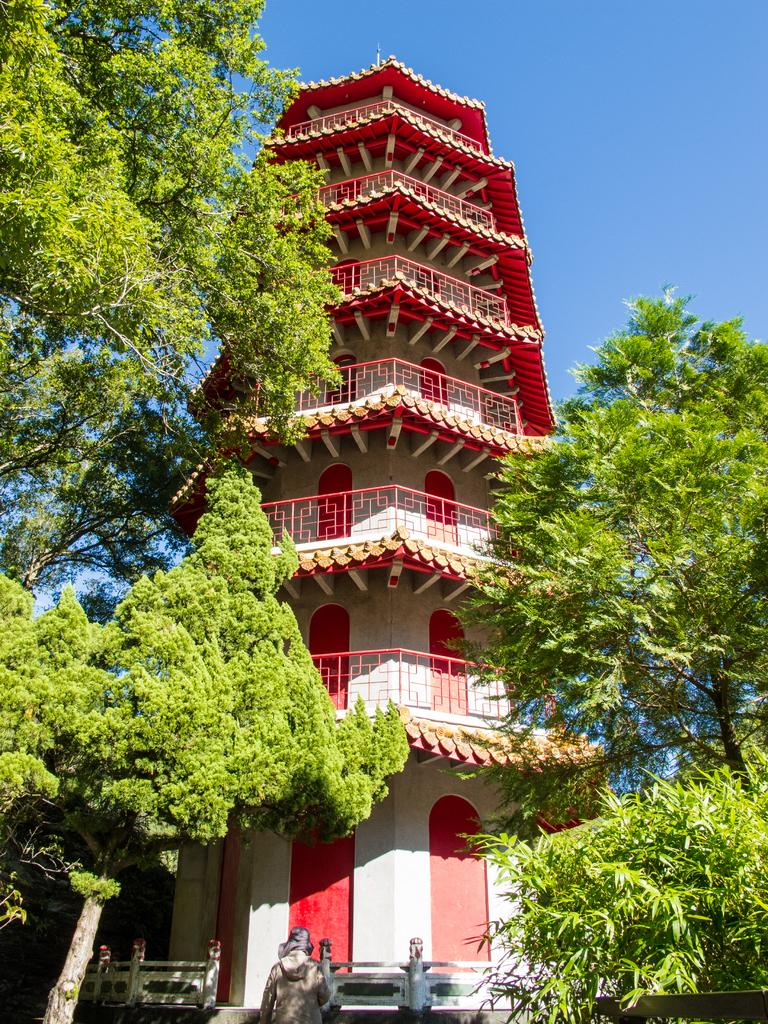What is the main subject in the middle of the image? There is a big structure in the middle of the image. What type of vegetation can be seen in the image? There are green trees in the image. What color is the sky at the top of the image? The sky is blue in color at the top of the image. Where is the partner sitting on the sofa in the image? There is no sofa or partner present in the image. 